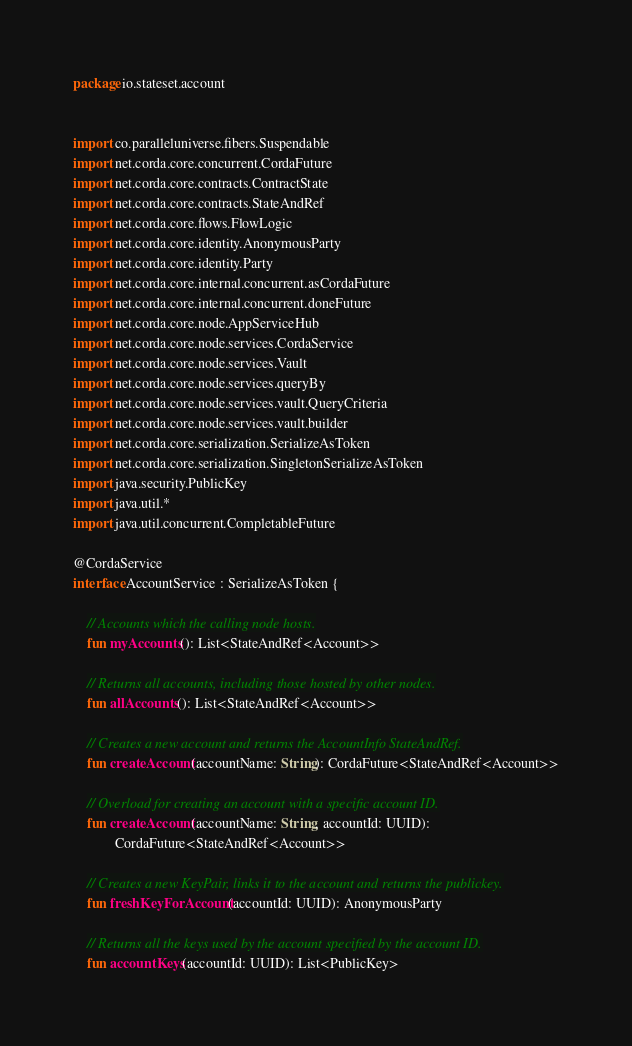<code> <loc_0><loc_0><loc_500><loc_500><_Kotlin_>package io.stateset.account


import co.paralleluniverse.fibers.Suspendable
import net.corda.core.concurrent.CordaFuture
import net.corda.core.contracts.ContractState
import net.corda.core.contracts.StateAndRef
import net.corda.core.flows.FlowLogic
import net.corda.core.identity.AnonymousParty
import net.corda.core.identity.Party
import net.corda.core.internal.concurrent.asCordaFuture
import net.corda.core.internal.concurrent.doneFuture
import net.corda.core.node.AppServiceHub
import net.corda.core.node.services.CordaService
import net.corda.core.node.services.Vault
import net.corda.core.node.services.queryBy
import net.corda.core.node.services.vault.QueryCriteria
import net.corda.core.node.services.vault.builder
import net.corda.core.serialization.SerializeAsToken
import net.corda.core.serialization.SingletonSerializeAsToken
import java.security.PublicKey
import java.util.*
import java.util.concurrent.CompletableFuture

@CordaService
interface AccountService : SerializeAsToken {

    // Accounts which the calling node hosts.
    fun myAccounts(): List<StateAndRef<Account>>

    // Returns all accounts, including those hosted by other nodes.
    fun allAccounts(): List<StateAndRef<Account>>

    // Creates a new account and returns the AccountInfo StateAndRef.
    fun createAccount(accountName: String): CordaFuture<StateAndRef<Account>>

    // Overload for creating an account with a specific account ID.
    fun createAccount(accountName: String, accountId: UUID):
            CordaFuture<StateAndRef<Account>>

    // Creates a new KeyPair, links it to the account and returns the publickey.
    fun freshKeyForAccount(accountId: UUID): AnonymousParty

    // Returns all the keys used by the account specified by the account ID.
    fun accountKeys(accountId: UUID): List<PublicKey>
</code> 